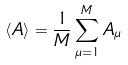<formula> <loc_0><loc_0><loc_500><loc_500>\langle A \rangle = \frac { 1 } { M } \sum _ { \mu = 1 } ^ { M } A _ { \mu }</formula> 